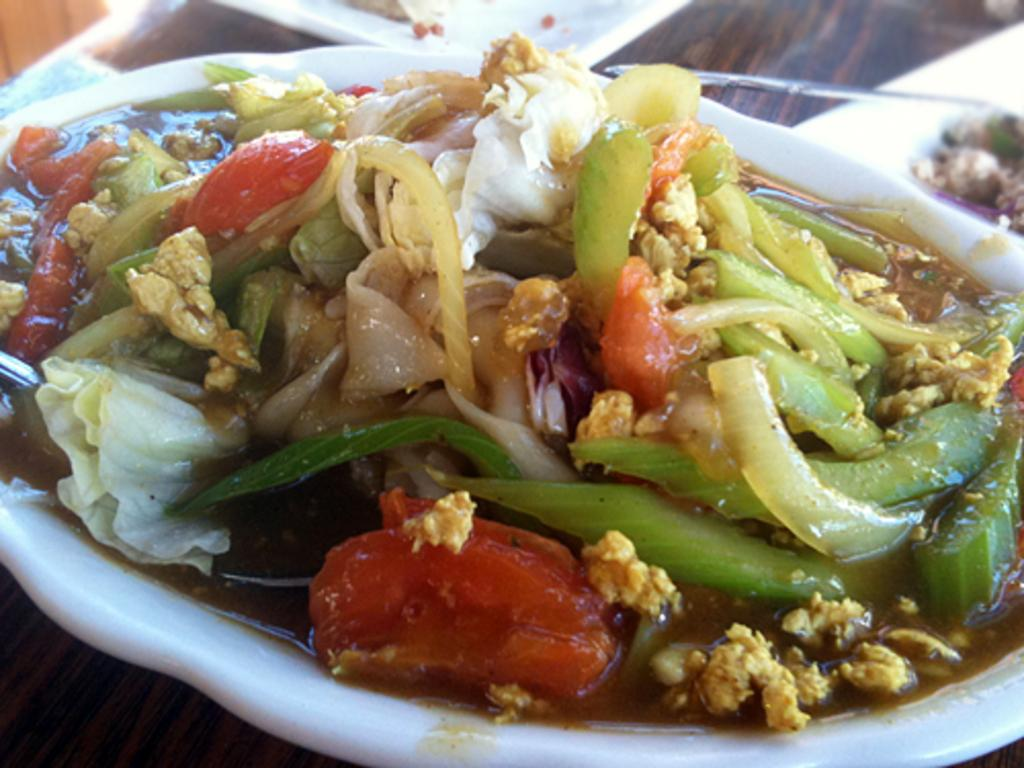What type of food is in the dish shown in the image? The food dish is made of vegetables. What color is the bowl that contains the food dish? The bowl is white. How many giants are visible in the image? There are no giants present in the image. What type of dust can be seen on the vegetables in the image? There is no dust visible on the vegetables in the image. 